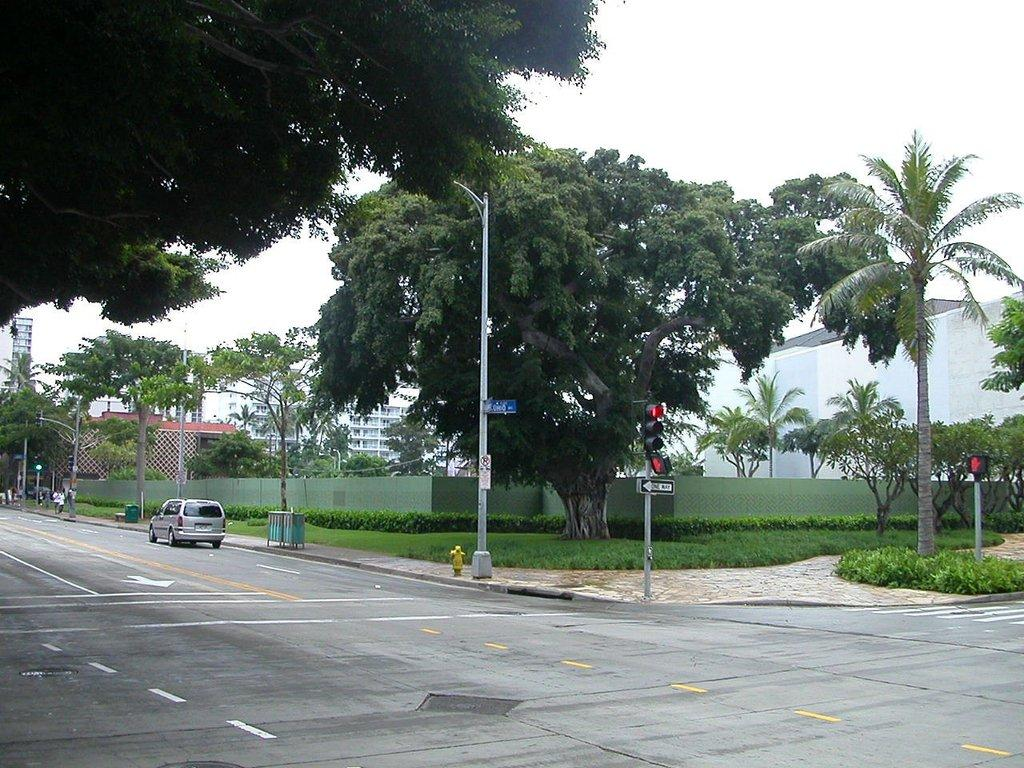What is on the road in the image? There is a vehicle on the road in the image. What can be seen to regulate traffic in the image? Traffic signals are present in the image. What is located on the footpath in the image? A lamp pole is visible on the footpath. What type of vegetation is present in the surroundings of the image? The area is surrounded by trees, and grass is present in the surroundings. What historical event is being commemorated by the vehicle in the image? The image does not depict any historical event or commemoration; it simply shows a vehicle on the road. 